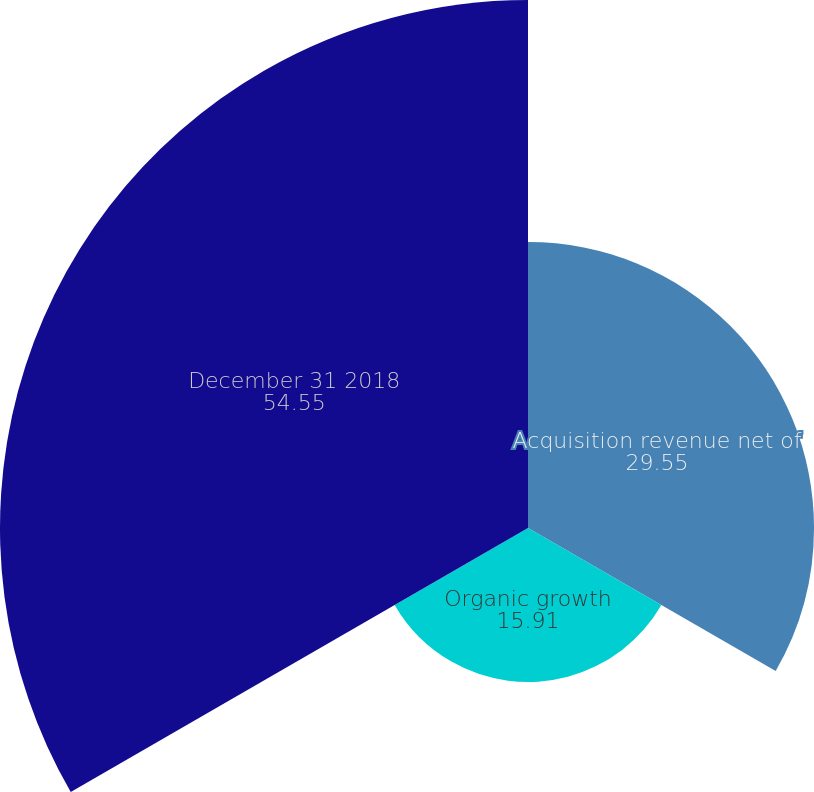<chart> <loc_0><loc_0><loc_500><loc_500><pie_chart><fcel>Acquisition revenue net of<fcel>Organic growth<fcel>December 31 2018<nl><fcel>29.55%<fcel>15.91%<fcel>54.55%<nl></chart> 